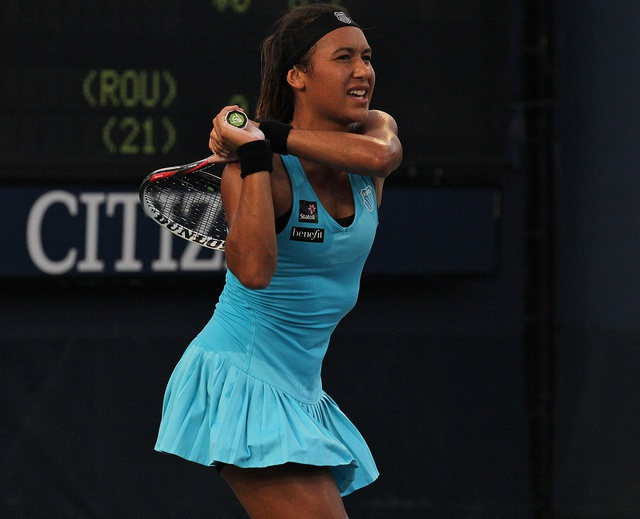Describe the objects in this image and their specific colors. I can see people in black, maroon, lightblue, and teal tones and tennis racket in black, gray, darkgray, and maroon tones in this image. 